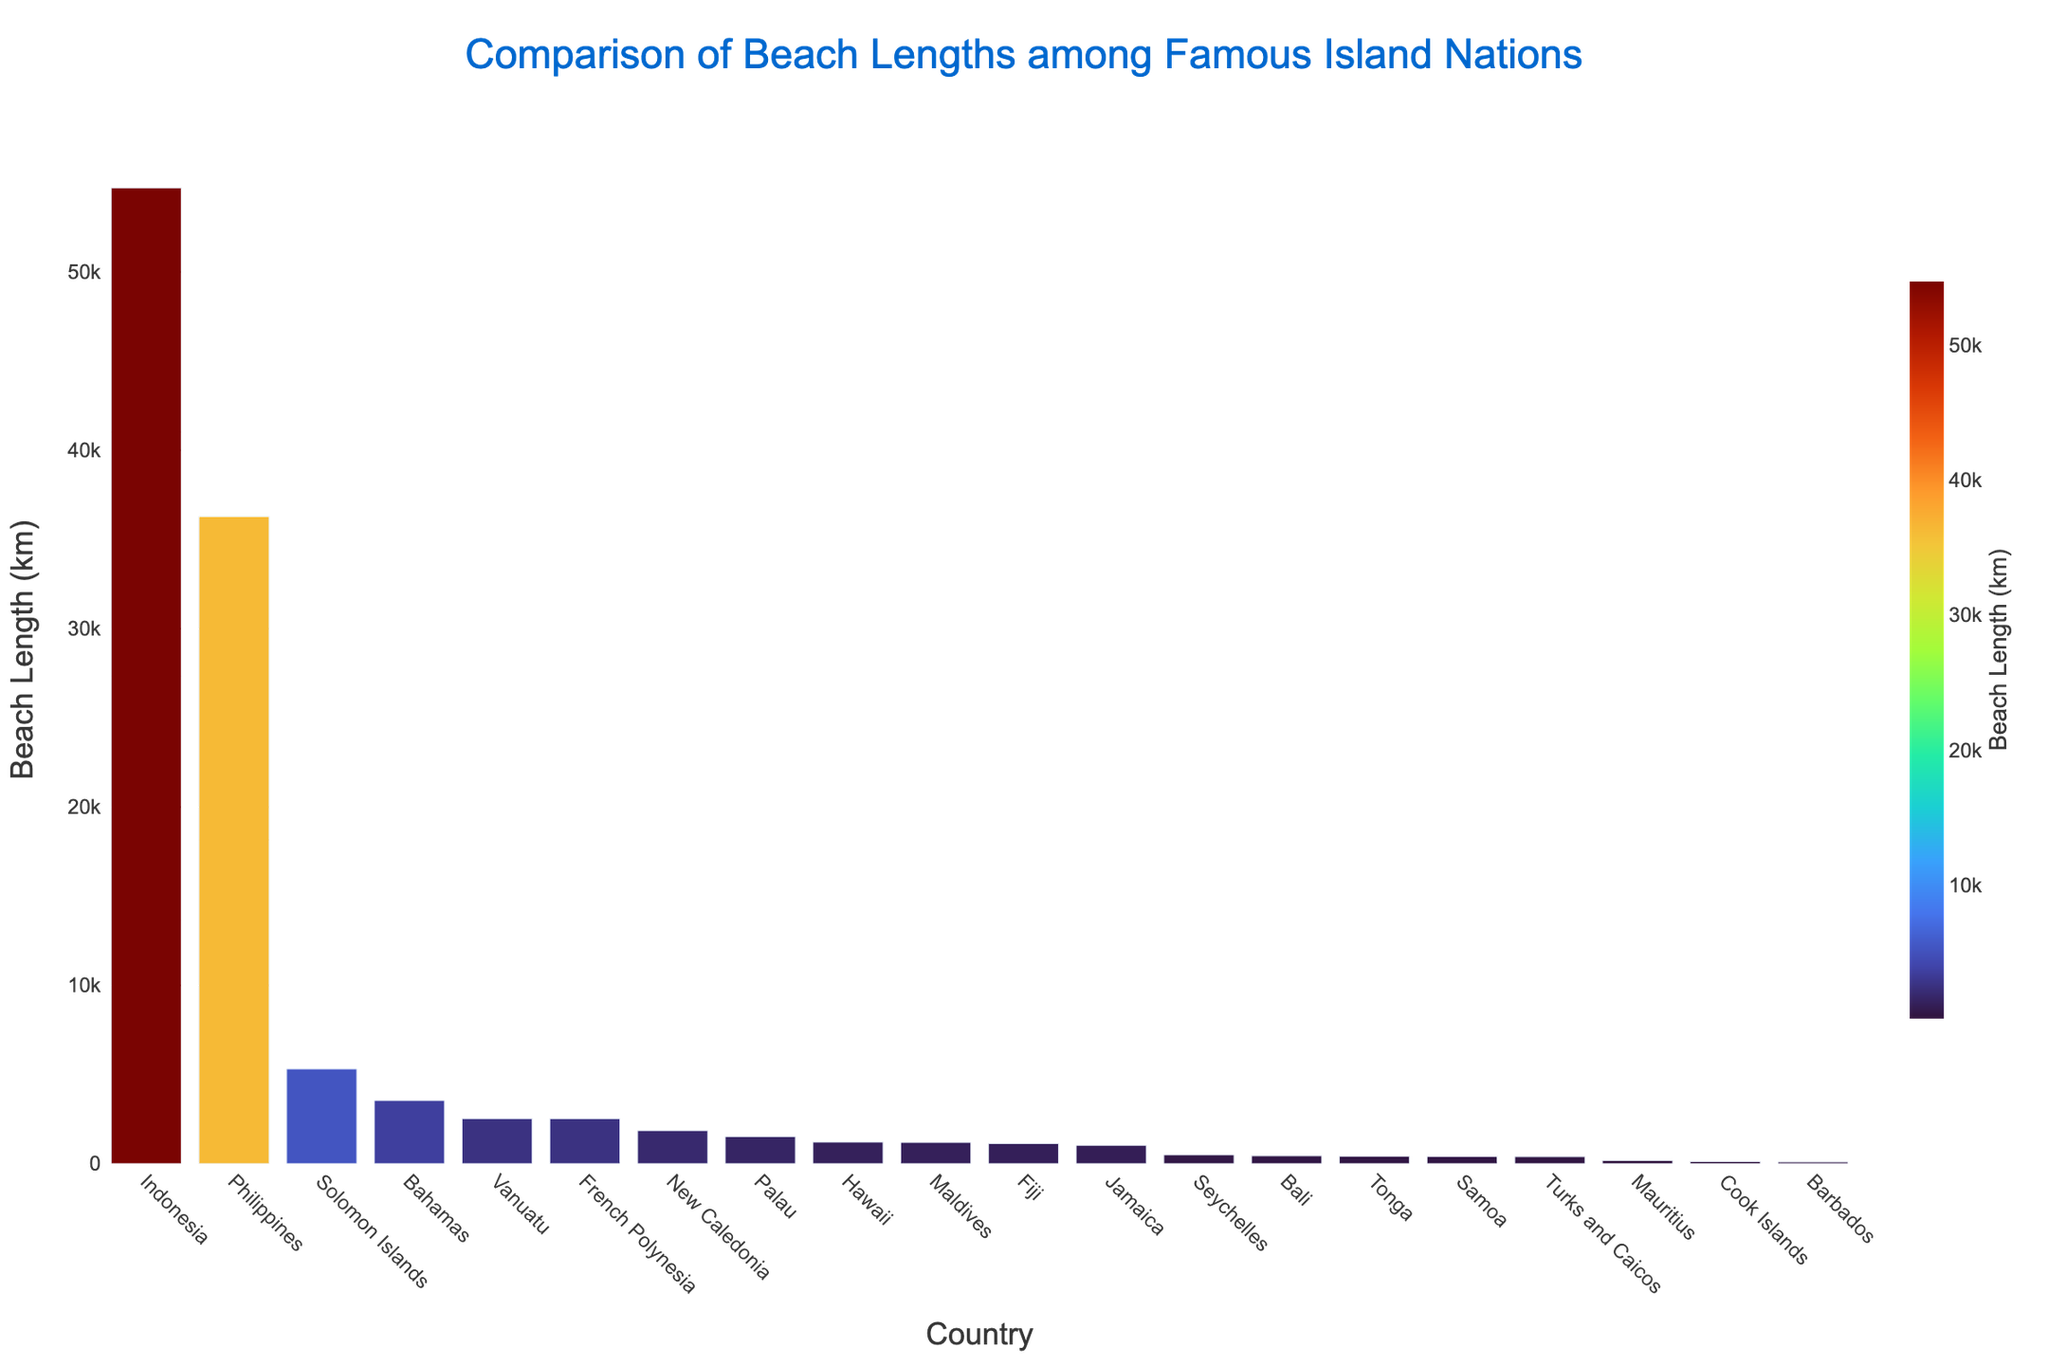Which country has the longest beach length? By looking at the bar chart, the tallest bar indicates the country with the longest beach length. Indonesia has the tallest bar.
Answer: Indonesia Which country has the shortest beach length? By identifying the shortest bar in the chart, we can see that Barbados has the shortest beach length.
Answer: Barbados How much longer is Indonesia's beach length compared to the Maldives? Indonesia's beach length is 54,716 km, and the Maldives' beach length is 1,192 km. Subtracting these: 54,716 - 1,192 = 53,524 km.
Answer: 53,524 km What is the combined beach length of Fiji, Jamaica, and Palau? Fiji has 1,129 km, Jamaica has 1,022 km, and Palau has 1,519 km. Adding these together: 1,129 + 1,022 + 1,519 = 3,670 km.
Answer: 3,670 km Which country has a beach length closest to that of Fiji? Observing nearby values in the chart, Hawaii's beach length (1,207 km) is closest to Fiji's beach length (1,129 km).
Answer: Hawaii Are there more countries with a beach length greater than 10,000 km or less than 1,000 km? By counting the number of bars above 10,000 km (Philippines and Indonesia, 2 countries) and below 1,000 km (Seychelles, Mauritius, Bali, Barbados, Cook Islands, Turks and Caicos, 6 countries), there are more countries with a beach length less than 1,000 km.
Answer: Less than 1,000 km What is the average beach length of the top 3 countries with the longest beaches? The top 3 countries are Indonesia (54,716 km), Philippines (36,289 km), and Solomon Islands (5,313 km). The average is (54,716 + 36,289 + 5,313) / 3 = 32,106 km.
Answer: 32,106 km Which country has a beach length most similar in color representation to Barbados? Since the color scale represents the length, and Barbados has a short beach length, similar colors would be for short beach lengths. Mauritius (177 km) is visually similar to Barbados (97 km).
Answer: Mauritius 